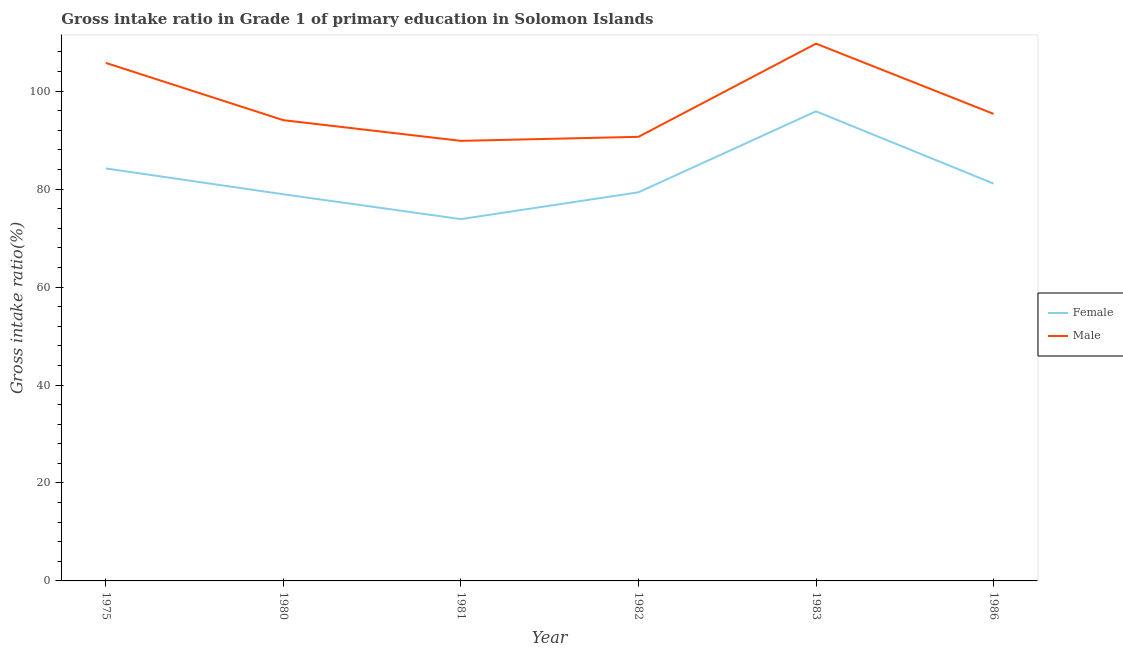How many different coloured lines are there?
Provide a succinct answer. 2. Does the line corresponding to gross intake ratio(male) intersect with the line corresponding to gross intake ratio(female)?
Make the answer very short. No. Is the number of lines equal to the number of legend labels?
Provide a short and direct response. Yes. What is the gross intake ratio(female) in 1975?
Make the answer very short. 84.22. Across all years, what is the maximum gross intake ratio(female)?
Offer a very short reply. 95.88. Across all years, what is the minimum gross intake ratio(male)?
Ensure brevity in your answer.  89.85. In which year was the gross intake ratio(male) maximum?
Make the answer very short. 1983. What is the total gross intake ratio(female) in the graph?
Your response must be concise. 493.39. What is the difference between the gross intake ratio(male) in 1975 and that in 1983?
Make the answer very short. -3.93. What is the difference between the gross intake ratio(male) in 1981 and the gross intake ratio(female) in 1975?
Offer a very short reply. 5.63. What is the average gross intake ratio(female) per year?
Provide a short and direct response. 82.23. In the year 1982, what is the difference between the gross intake ratio(female) and gross intake ratio(male)?
Your answer should be very brief. -11.32. What is the ratio of the gross intake ratio(female) in 1980 to that in 1986?
Your response must be concise. 0.97. Is the gross intake ratio(female) in 1975 less than that in 1981?
Keep it short and to the point. No. Is the difference between the gross intake ratio(female) in 1975 and 1983 greater than the difference between the gross intake ratio(male) in 1975 and 1983?
Provide a short and direct response. No. What is the difference between the highest and the second highest gross intake ratio(male)?
Offer a very short reply. 3.93. What is the difference between the highest and the lowest gross intake ratio(female)?
Keep it short and to the point. 22.01. Is the sum of the gross intake ratio(female) in 1975 and 1982 greater than the maximum gross intake ratio(male) across all years?
Ensure brevity in your answer.  Yes. Does the gross intake ratio(female) monotonically increase over the years?
Give a very brief answer. No. Is the gross intake ratio(male) strictly greater than the gross intake ratio(female) over the years?
Provide a succinct answer. Yes. Is the gross intake ratio(female) strictly less than the gross intake ratio(male) over the years?
Your answer should be very brief. Yes. Are the values on the major ticks of Y-axis written in scientific E-notation?
Keep it short and to the point. No. Does the graph contain grids?
Your answer should be compact. No. Where does the legend appear in the graph?
Keep it short and to the point. Center right. How many legend labels are there?
Keep it short and to the point. 2. What is the title of the graph?
Ensure brevity in your answer.  Gross intake ratio in Grade 1 of primary education in Solomon Islands. What is the label or title of the X-axis?
Your answer should be very brief. Year. What is the label or title of the Y-axis?
Ensure brevity in your answer.  Gross intake ratio(%). What is the Gross intake ratio(%) of Female in 1975?
Ensure brevity in your answer.  84.22. What is the Gross intake ratio(%) in Male in 1975?
Give a very brief answer. 105.77. What is the Gross intake ratio(%) in Female in 1980?
Give a very brief answer. 78.95. What is the Gross intake ratio(%) of Male in 1980?
Offer a very short reply. 94.07. What is the Gross intake ratio(%) of Female in 1981?
Provide a short and direct response. 73.87. What is the Gross intake ratio(%) of Male in 1981?
Provide a short and direct response. 89.85. What is the Gross intake ratio(%) of Female in 1982?
Your response must be concise. 79.35. What is the Gross intake ratio(%) in Male in 1982?
Your response must be concise. 90.67. What is the Gross intake ratio(%) of Female in 1983?
Provide a succinct answer. 95.88. What is the Gross intake ratio(%) in Male in 1983?
Offer a terse response. 109.7. What is the Gross intake ratio(%) in Female in 1986?
Provide a succinct answer. 81.12. What is the Gross intake ratio(%) in Male in 1986?
Offer a very short reply. 95.36. Across all years, what is the maximum Gross intake ratio(%) of Female?
Provide a succinct answer. 95.88. Across all years, what is the maximum Gross intake ratio(%) of Male?
Your response must be concise. 109.7. Across all years, what is the minimum Gross intake ratio(%) in Female?
Keep it short and to the point. 73.87. Across all years, what is the minimum Gross intake ratio(%) of Male?
Your answer should be compact. 89.85. What is the total Gross intake ratio(%) in Female in the graph?
Your response must be concise. 493.39. What is the total Gross intake ratio(%) of Male in the graph?
Provide a succinct answer. 585.42. What is the difference between the Gross intake ratio(%) in Female in 1975 and that in 1980?
Give a very brief answer. 5.27. What is the difference between the Gross intake ratio(%) in Male in 1975 and that in 1980?
Keep it short and to the point. 11.69. What is the difference between the Gross intake ratio(%) in Female in 1975 and that in 1981?
Keep it short and to the point. 10.35. What is the difference between the Gross intake ratio(%) of Male in 1975 and that in 1981?
Provide a short and direct response. 15.92. What is the difference between the Gross intake ratio(%) of Female in 1975 and that in 1982?
Your answer should be compact. 4.87. What is the difference between the Gross intake ratio(%) in Male in 1975 and that in 1982?
Offer a terse response. 15.1. What is the difference between the Gross intake ratio(%) of Female in 1975 and that in 1983?
Keep it short and to the point. -11.66. What is the difference between the Gross intake ratio(%) in Male in 1975 and that in 1983?
Your answer should be compact. -3.93. What is the difference between the Gross intake ratio(%) of Female in 1975 and that in 1986?
Ensure brevity in your answer.  3.1. What is the difference between the Gross intake ratio(%) in Male in 1975 and that in 1986?
Give a very brief answer. 10.41. What is the difference between the Gross intake ratio(%) in Female in 1980 and that in 1981?
Your answer should be compact. 5.07. What is the difference between the Gross intake ratio(%) in Male in 1980 and that in 1981?
Offer a very short reply. 4.23. What is the difference between the Gross intake ratio(%) in Female in 1980 and that in 1982?
Provide a short and direct response. -0.41. What is the difference between the Gross intake ratio(%) of Male in 1980 and that in 1982?
Ensure brevity in your answer.  3.4. What is the difference between the Gross intake ratio(%) of Female in 1980 and that in 1983?
Provide a succinct answer. -16.94. What is the difference between the Gross intake ratio(%) of Male in 1980 and that in 1983?
Your response must be concise. -15.62. What is the difference between the Gross intake ratio(%) in Female in 1980 and that in 1986?
Your answer should be compact. -2.17. What is the difference between the Gross intake ratio(%) in Male in 1980 and that in 1986?
Offer a terse response. -1.28. What is the difference between the Gross intake ratio(%) of Female in 1981 and that in 1982?
Ensure brevity in your answer.  -5.48. What is the difference between the Gross intake ratio(%) in Male in 1981 and that in 1982?
Your answer should be compact. -0.82. What is the difference between the Gross intake ratio(%) of Female in 1981 and that in 1983?
Your answer should be very brief. -22.01. What is the difference between the Gross intake ratio(%) of Male in 1981 and that in 1983?
Your answer should be compact. -19.85. What is the difference between the Gross intake ratio(%) in Female in 1981 and that in 1986?
Give a very brief answer. -7.25. What is the difference between the Gross intake ratio(%) in Male in 1981 and that in 1986?
Your response must be concise. -5.51. What is the difference between the Gross intake ratio(%) of Female in 1982 and that in 1983?
Give a very brief answer. -16.53. What is the difference between the Gross intake ratio(%) in Male in 1982 and that in 1983?
Your answer should be very brief. -19.03. What is the difference between the Gross intake ratio(%) in Female in 1982 and that in 1986?
Ensure brevity in your answer.  -1.77. What is the difference between the Gross intake ratio(%) of Male in 1982 and that in 1986?
Your answer should be very brief. -4.68. What is the difference between the Gross intake ratio(%) of Female in 1983 and that in 1986?
Provide a succinct answer. 14.76. What is the difference between the Gross intake ratio(%) of Male in 1983 and that in 1986?
Make the answer very short. 14.34. What is the difference between the Gross intake ratio(%) in Female in 1975 and the Gross intake ratio(%) in Male in 1980?
Ensure brevity in your answer.  -9.86. What is the difference between the Gross intake ratio(%) of Female in 1975 and the Gross intake ratio(%) of Male in 1981?
Offer a terse response. -5.63. What is the difference between the Gross intake ratio(%) of Female in 1975 and the Gross intake ratio(%) of Male in 1982?
Provide a short and direct response. -6.46. What is the difference between the Gross intake ratio(%) of Female in 1975 and the Gross intake ratio(%) of Male in 1983?
Your response must be concise. -25.48. What is the difference between the Gross intake ratio(%) in Female in 1975 and the Gross intake ratio(%) in Male in 1986?
Your response must be concise. -11.14. What is the difference between the Gross intake ratio(%) of Female in 1980 and the Gross intake ratio(%) of Male in 1981?
Give a very brief answer. -10.9. What is the difference between the Gross intake ratio(%) in Female in 1980 and the Gross intake ratio(%) in Male in 1982?
Ensure brevity in your answer.  -11.73. What is the difference between the Gross intake ratio(%) in Female in 1980 and the Gross intake ratio(%) in Male in 1983?
Your answer should be very brief. -30.75. What is the difference between the Gross intake ratio(%) in Female in 1980 and the Gross intake ratio(%) in Male in 1986?
Your response must be concise. -16.41. What is the difference between the Gross intake ratio(%) of Female in 1981 and the Gross intake ratio(%) of Male in 1982?
Offer a very short reply. -16.8. What is the difference between the Gross intake ratio(%) in Female in 1981 and the Gross intake ratio(%) in Male in 1983?
Your answer should be very brief. -35.83. What is the difference between the Gross intake ratio(%) of Female in 1981 and the Gross intake ratio(%) of Male in 1986?
Make the answer very short. -21.48. What is the difference between the Gross intake ratio(%) in Female in 1982 and the Gross intake ratio(%) in Male in 1983?
Your answer should be compact. -30.35. What is the difference between the Gross intake ratio(%) in Female in 1982 and the Gross intake ratio(%) in Male in 1986?
Make the answer very short. -16. What is the difference between the Gross intake ratio(%) in Female in 1983 and the Gross intake ratio(%) in Male in 1986?
Your answer should be compact. 0.53. What is the average Gross intake ratio(%) in Female per year?
Keep it short and to the point. 82.23. What is the average Gross intake ratio(%) of Male per year?
Ensure brevity in your answer.  97.57. In the year 1975, what is the difference between the Gross intake ratio(%) of Female and Gross intake ratio(%) of Male?
Provide a short and direct response. -21.55. In the year 1980, what is the difference between the Gross intake ratio(%) of Female and Gross intake ratio(%) of Male?
Ensure brevity in your answer.  -15.13. In the year 1981, what is the difference between the Gross intake ratio(%) in Female and Gross intake ratio(%) in Male?
Give a very brief answer. -15.98. In the year 1982, what is the difference between the Gross intake ratio(%) in Female and Gross intake ratio(%) in Male?
Ensure brevity in your answer.  -11.32. In the year 1983, what is the difference between the Gross intake ratio(%) in Female and Gross intake ratio(%) in Male?
Offer a very short reply. -13.82. In the year 1986, what is the difference between the Gross intake ratio(%) of Female and Gross intake ratio(%) of Male?
Keep it short and to the point. -14.24. What is the ratio of the Gross intake ratio(%) in Female in 1975 to that in 1980?
Offer a terse response. 1.07. What is the ratio of the Gross intake ratio(%) of Male in 1975 to that in 1980?
Your answer should be very brief. 1.12. What is the ratio of the Gross intake ratio(%) in Female in 1975 to that in 1981?
Your answer should be very brief. 1.14. What is the ratio of the Gross intake ratio(%) in Male in 1975 to that in 1981?
Provide a short and direct response. 1.18. What is the ratio of the Gross intake ratio(%) in Female in 1975 to that in 1982?
Keep it short and to the point. 1.06. What is the ratio of the Gross intake ratio(%) of Male in 1975 to that in 1982?
Make the answer very short. 1.17. What is the ratio of the Gross intake ratio(%) in Female in 1975 to that in 1983?
Ensure brevity in your answer.  0.88. What is the ratio of the Gross intake ratio(%) in Male in 1975 to that in 1983?
Your answer should be compact. 0.96. What is the ratio of the Gross intake ratio(%) in Female in 1975 to that in 1986?
Offer a very short reply. 1.04. What is the ratio of the Gross intake ratio(%) of Male in 1975 to that in 1986?
Give a very brief answer. 1.11. What is the ratio of the Gross intake ratio(%) in Female in 1980 to that in 1981?
Provide a succinct answer. 1.07. What is the ratio of the Gross intake ratio(%) in Male in 1980 to that in 1981?
Provide a succinct answer. 1.05. What is the ratio of the Gross intake ratio(%) in Female in 1980 to that in 1982?
Give a very brief answer. 0.99. What is the ratio of the Gross intake ratio(%) in Male in 1980 to that in 1982?
Your answer should be very brief. 1.04. What is the ratio of the Gross intake ratio(%) of Female in 1980 to that in 1983?
Offer a very short reply. 0.82. What is the ratio of the Gross intake ratio(%) of Male in 1980 to that in 1983?
Your answer should be very brief. 0.86. What is the ratio of the Gross intake ratio(%) in Female in 1980 to that in 1986?
Ensure brevity in your answer.  0.97. What is the ratio of the Gross intake ratio(%) in Male in 1980 to that in 1986?
Your answer should be very brief. 0.99. What is the ratio of the Gross intake ratio(%) in Female in 1981 to that in 1982?
Your answer should be very brief. 0.93. What is the ratio of the Gross intake ratio(%) in Male in 1981 to that in 1982?
Provide a short and direct response. 0.99. What is the ratio of the Gross intake ratio(%) in Female in 1981 to that in 1983?
Make the answer very short. 0.77. What is the ratio of the Gross intake ratio(%) in Male in 1981 to that in 1983?
Provide a short and direct response. 0.82. What is the ratio of the Gross intake ratio(%) of Female in 1981 to that in 1986?
Your response must be concise. 0.91. What is the ratio of the Gross intake ratio(%) of Male in 1981 to that in 1986?
Offer a terse response. 0.94. What is the ratio of the Gross intake ratio(%) of Female in 1982 to that in 1983?
Offer a terse response. 0.83. What is the ratio of the Gross intake ratio(%) of Male in 1982 to that in 1983?
Offer a terse response. 0.83. What is the ratio of the Gross intake ratio(%) of Female in 1982 to that in 1986?
Offer a terse response. 0.98. What is the ratio of the Gross intake ratio(%) in Male in 1982 to that in 1986?
Provide a succinct answer. 0.95. What is the ratio of the Gross intake ratio(%) in Female in 1983 to that in 1986?
Your answer should be compact. 1.18. What is the ratio of the Gross intake ratio(%) of Male in 1983 to that in 1986?
Make the answer very short. 1.15. What is the difference between the highest and the second highest Gross intake ratio(%) of Female?
Your response must be concise. 11.66. What is the difference between the highest and the second highest Gross intake ratio(%) in Male?
Provide a short and direct response. 3.93. What is the difference between the highest and the lowest Gross intake ratio(%) of Female?
Provide a short and direct response. 22.01. What is the difference between the highest and the lowest Gross intake ratio(%) in Male?
Give a very brief answer. 19.85. 